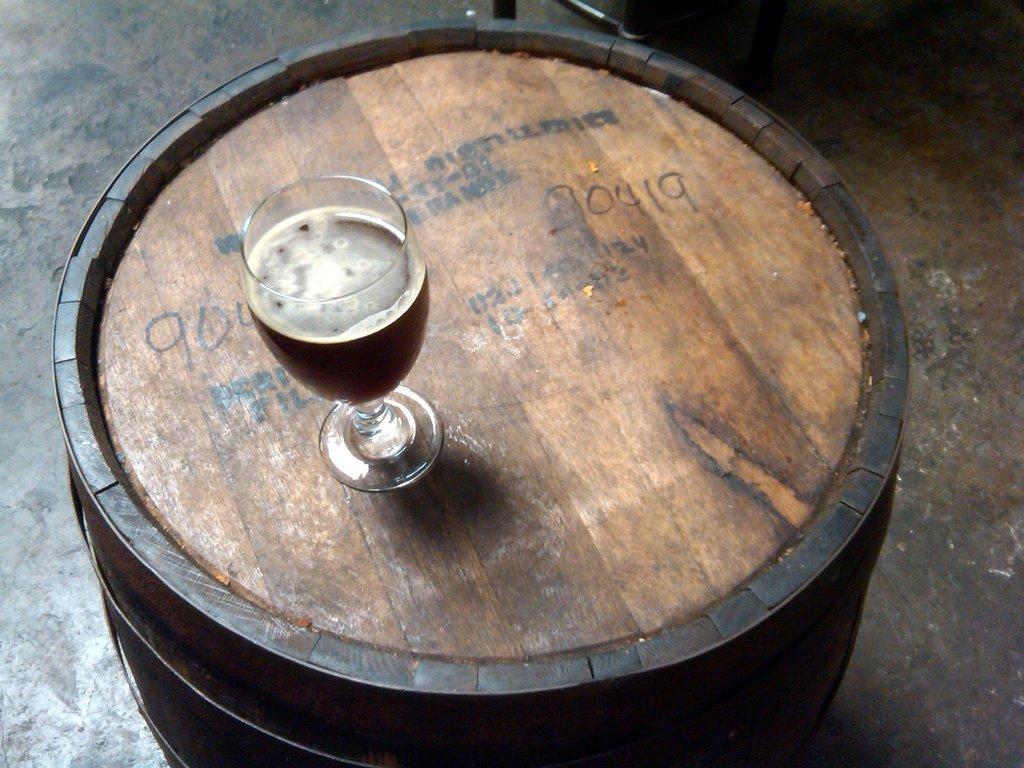How would you summarize this image in a sentence or two? In the foreground I can see a circular table on which a glass is kept. In the background I can see floor. This image is taken may be in a hall. 